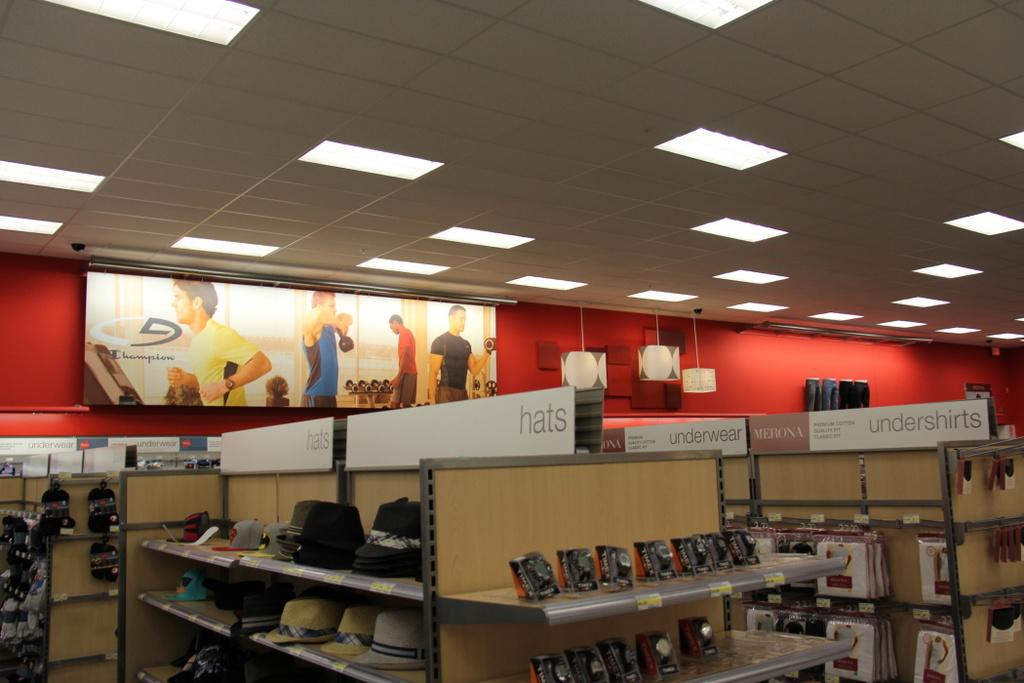What type of decorations can be seen on the wall in the image? There are posters and a banner on the wall in the image. What color is the wall in the image? The wall is red in color. What type of illumination is present in the image? There are lights in the image. What items can be seen on the shelves in the image? On the shelves, there are hats, bags, watches, and covers. What type of honey can be seen dripping from the banner in the image? There is no honey present in the image; it only features posters, a banner, a red wall, lights, and shelves with various items. 